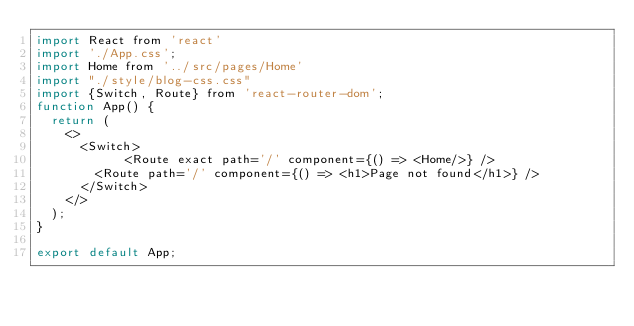<code> <loc_0><loc_0><loc_500><loc_500><_JavaScript_>import React from 'react'
import './App.css';
import Home from '../src/pages/Home'
import "./style/blog-css.css"
import {Switch, Route} from 'react-router-dom';
function App() {
  return (
    <>
      <Switch>
            <Route exact path='/' component={() => <Home/>} />
        <Route path='/' component={() => <h1>Page not found</h1>} />
      </Switch>
    </>
  );
}

export default App;
</code> 